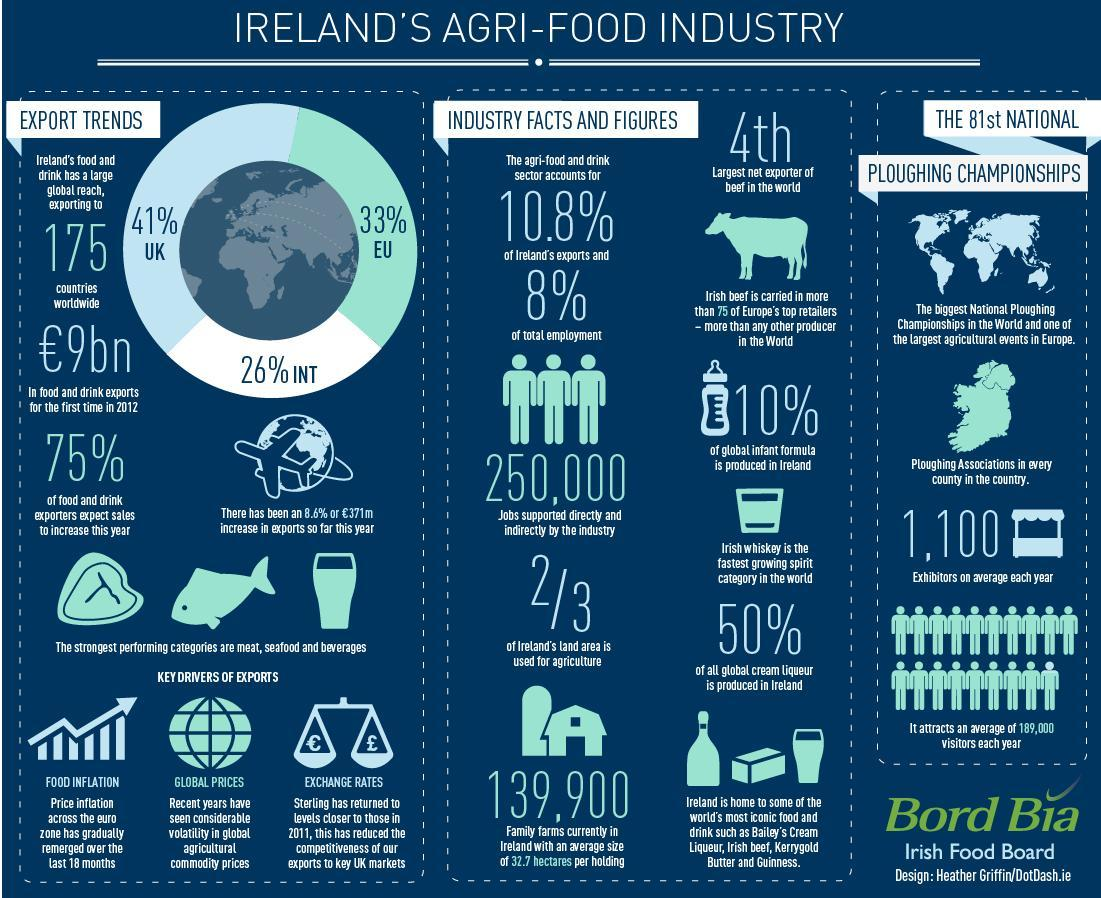What percentage of Ireland's food & drink is exported to the UK?
Answer the question with a short phrase. 41% What percentage of the global infant formula is not produced in Ireland? 90% What percentage of all global cream liqueur is produced in Ireland? 50% 